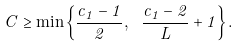<formula> <loc_0><loc_0><loc_500><loc_500>C \geq \min \left \{ \frac { c _ { 1 } - 1 } { 2 } , \ \frac { c _ { 1 } - 2 } { L } + 1 \right \} .</formula> 